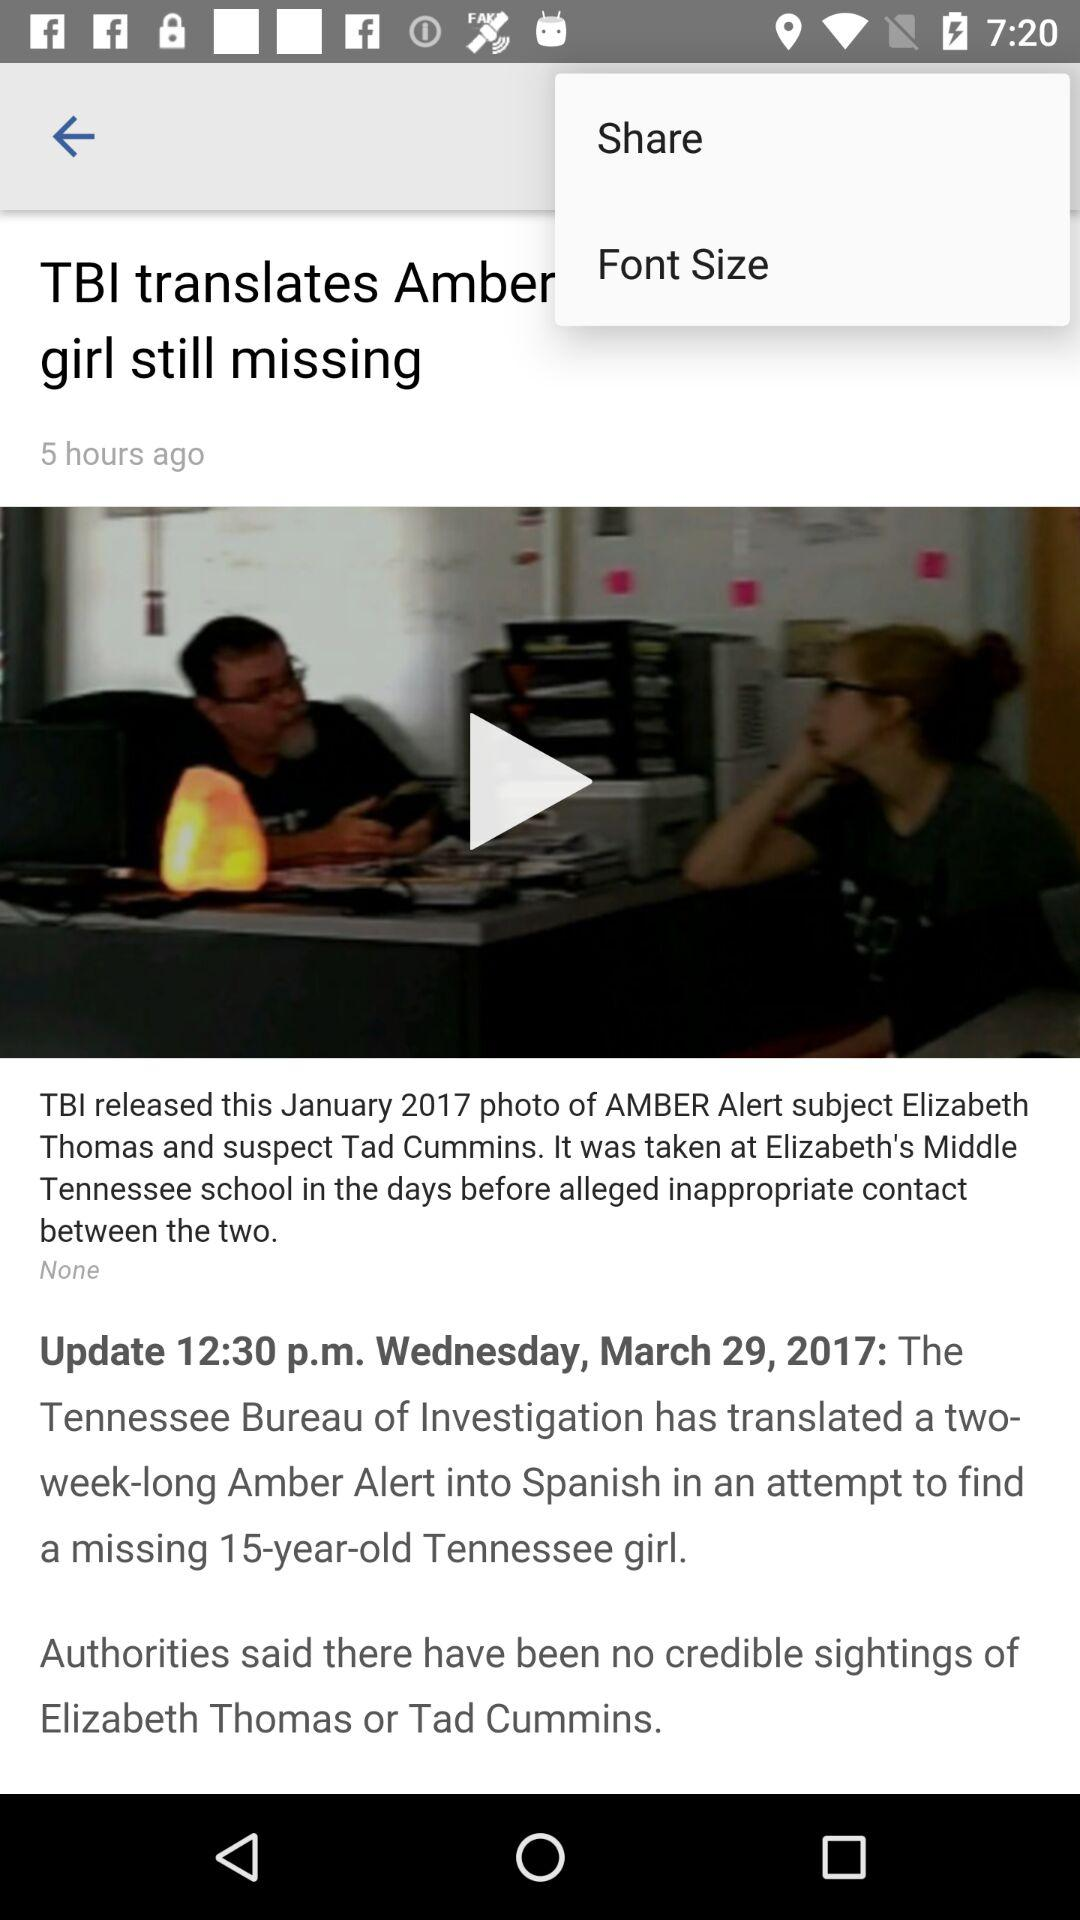How old is the girl? The girl is 15 years old. 